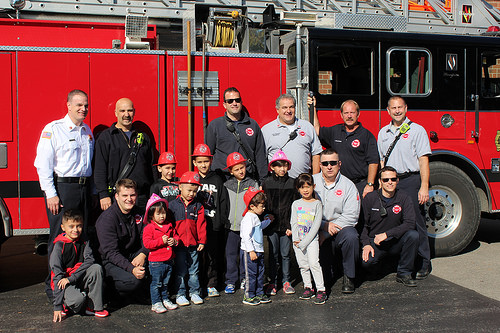<image>
Is there a man on the vehicle? Yes. Looking at the image, I can see the man is positioned on top of the vehicle, with the vehicle providing support. Is there a child to the right of the man? Yes. From this viewpoint, the child is positioned to the right side relative to the man. 